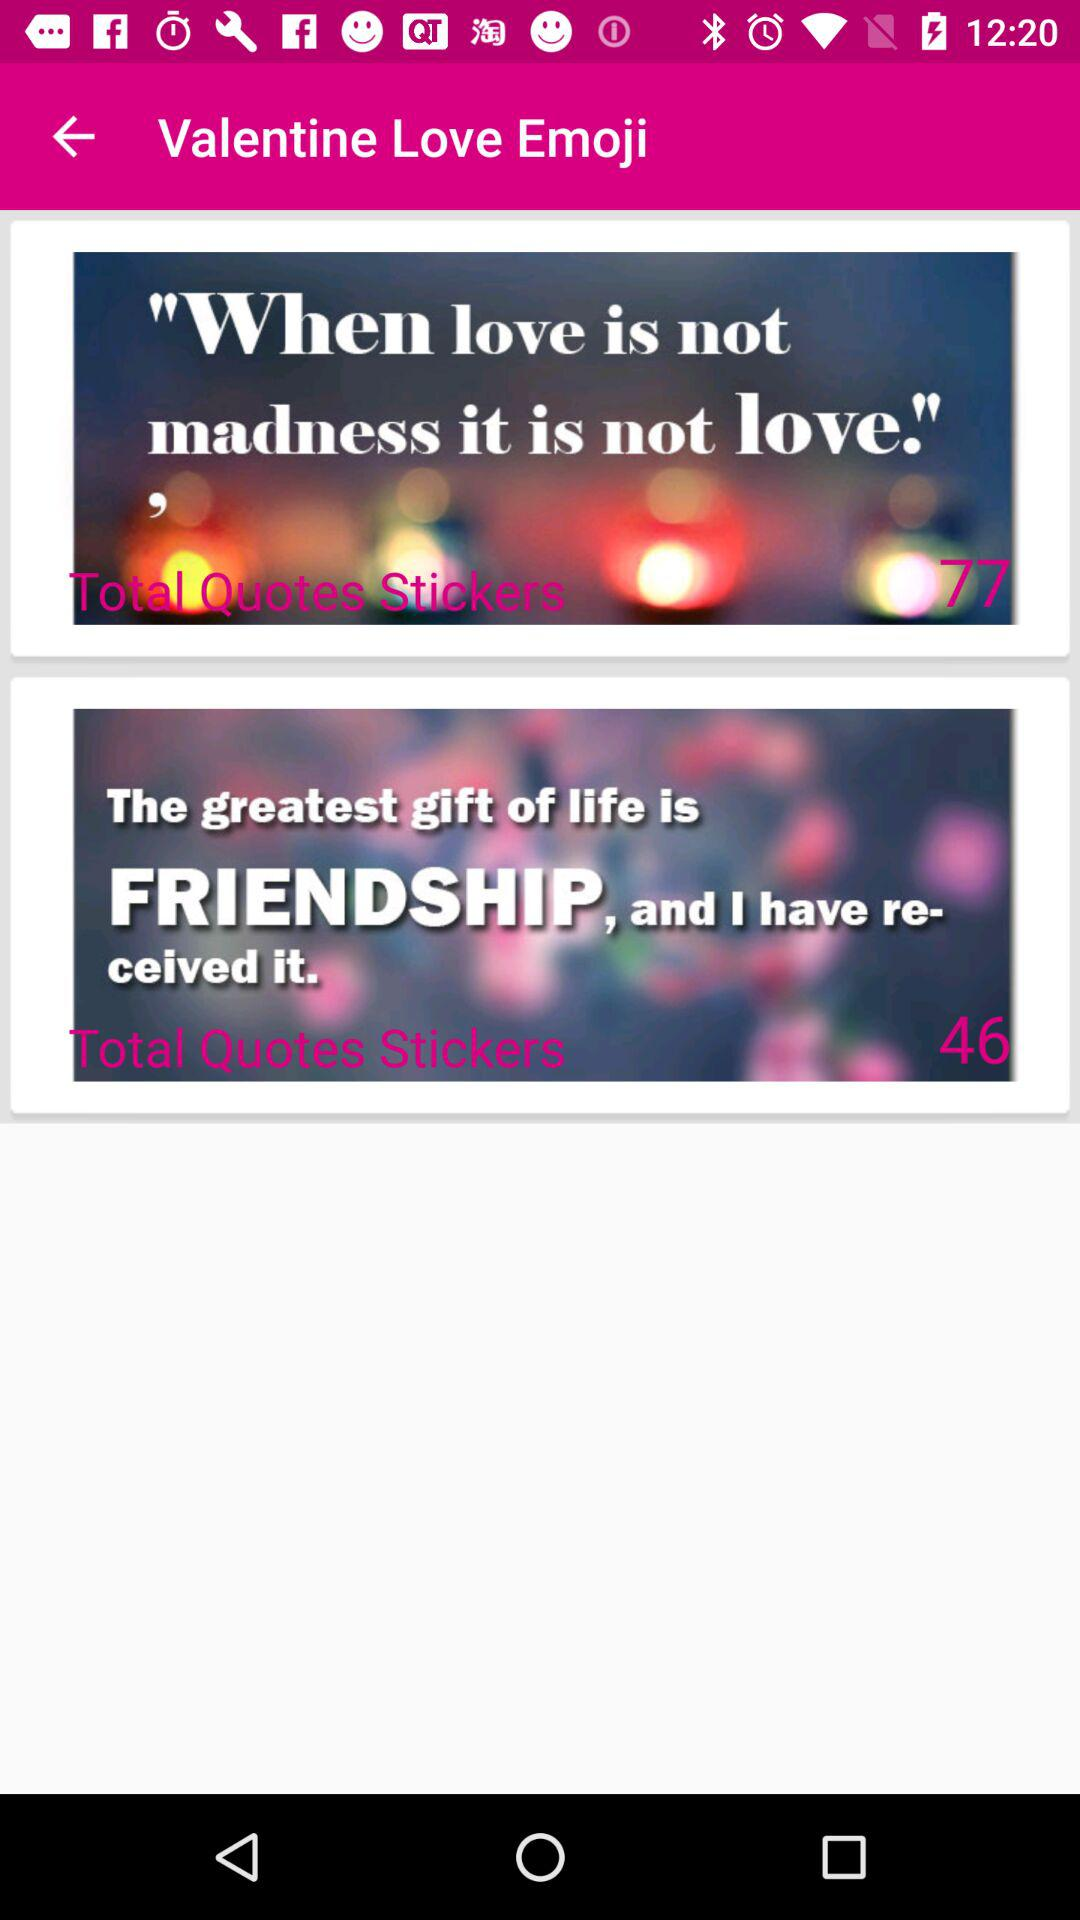What is the total number of quotes on love?
When the provided information is insufficient, respond with <no answer>. <no answer> 